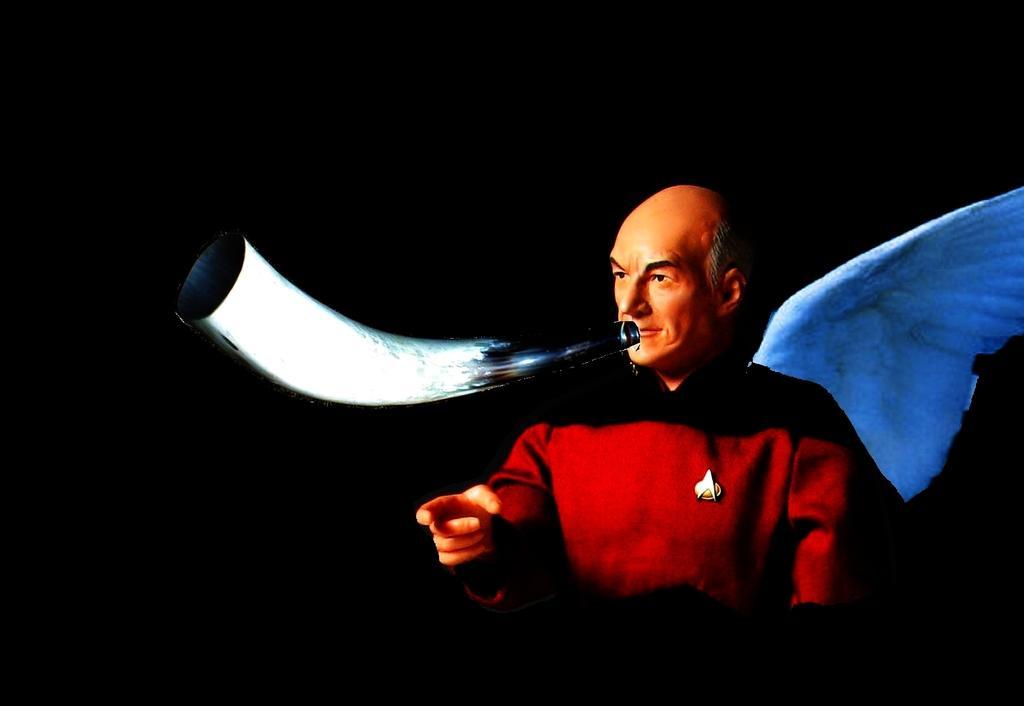Can you describe this image briefly? This is an animated image. In this image I can see the person with the dress and I can see the black and white color objects. I can see the black background. 